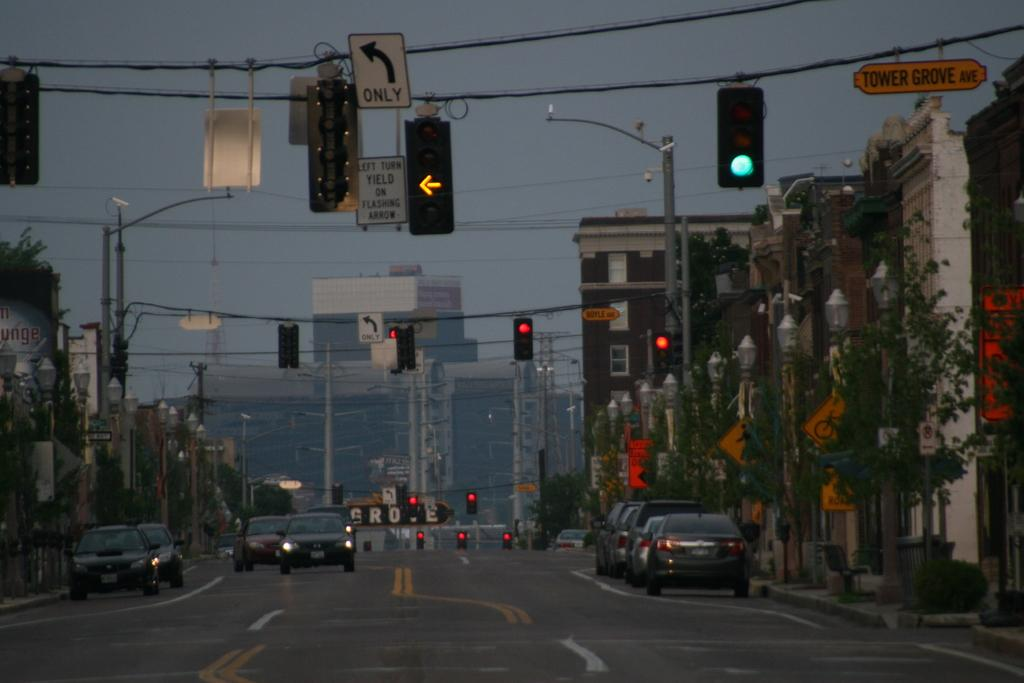<image>
Summarize the visual content of the image. The first cross street is Tower Grove Ave. 